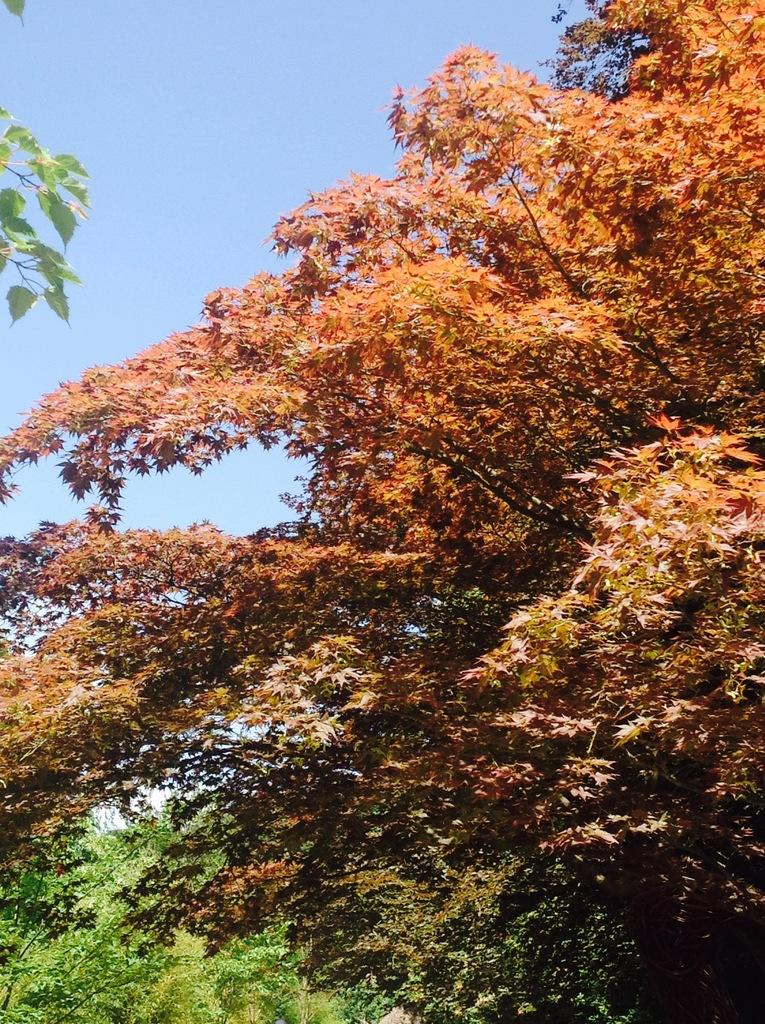What type of vegetation is present in the image? There are trees in the image. What features can be observed on the trees? The trees have branches and leaves. What colors are the leaves on the trees? The leaves are green and light orange in color. What else can be seen in the image besides the trees? The sky is visible in the image. How does the visitor interact with the trees in the image? There is no visitor present in the image; it only features trees and the sky. 